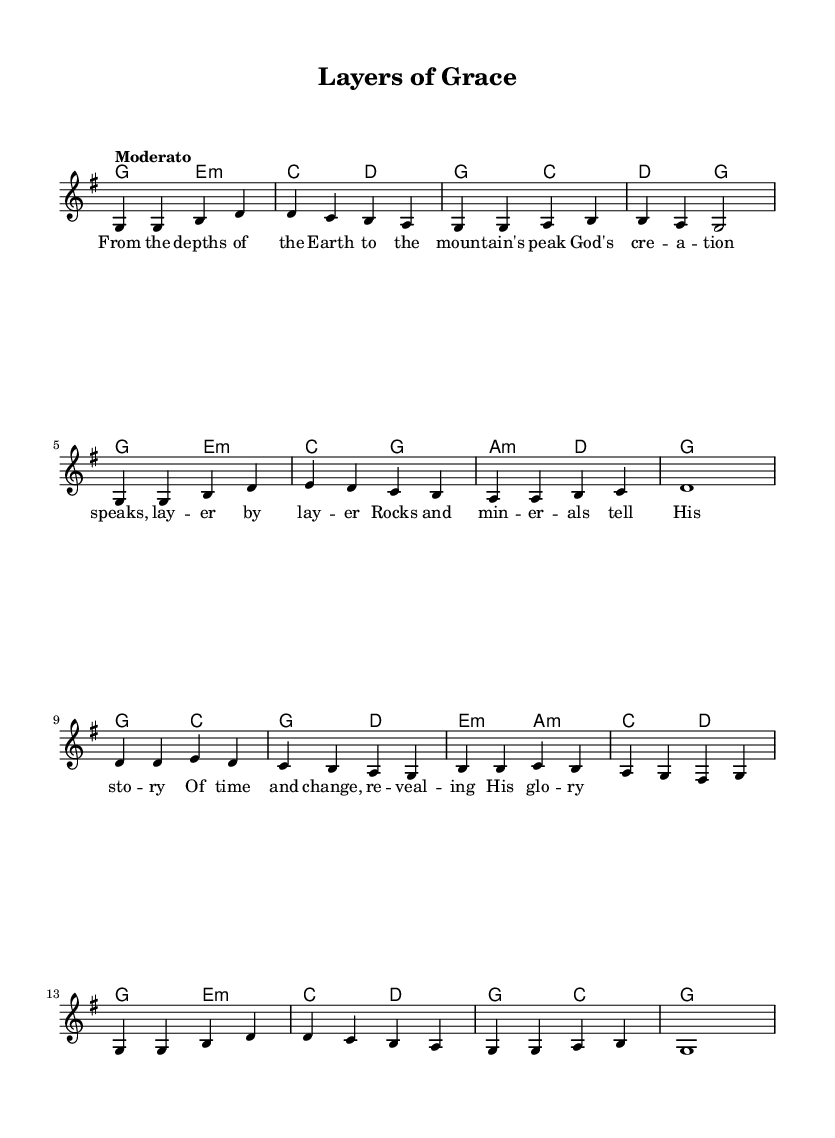What is the key signature of this music? The key signature is indicated by the presence of one sharp (F#) and no flats, which is characteristic of G major.
Answer: G major What is the time signature? The time signature is shown at the beginning of the score and is represented as "4/4," which indicates that there are four beats per measure and a quarter note gets one beat.
Answer: 4/4 What is the tempo marking? The tempo marking is located at the beginning of the sheet music, and it simply states "Moderato," which suggests a moderate speed for the piece.
Answer: Moderato How many measures are in the melody? By counting the distinct sets of note values separated by bar lines in the melody part, we find that there are a total of 16 measures present.
Answer: 16 What is the first note of the melody? The first note of the melody is seen at the beginning of the staff, which is the note G.
Answer: G What type of chord is used in the second measure? The second measure contains the chord C, which is a major chord consisting of the notes C, E, and G.
Answer: C What thematic concept is reflected in the lyrics? The lyrics convey themes of creation and natural elements, specifically focusing on geological processes and their connection to divine creation.
Answer: Creation 